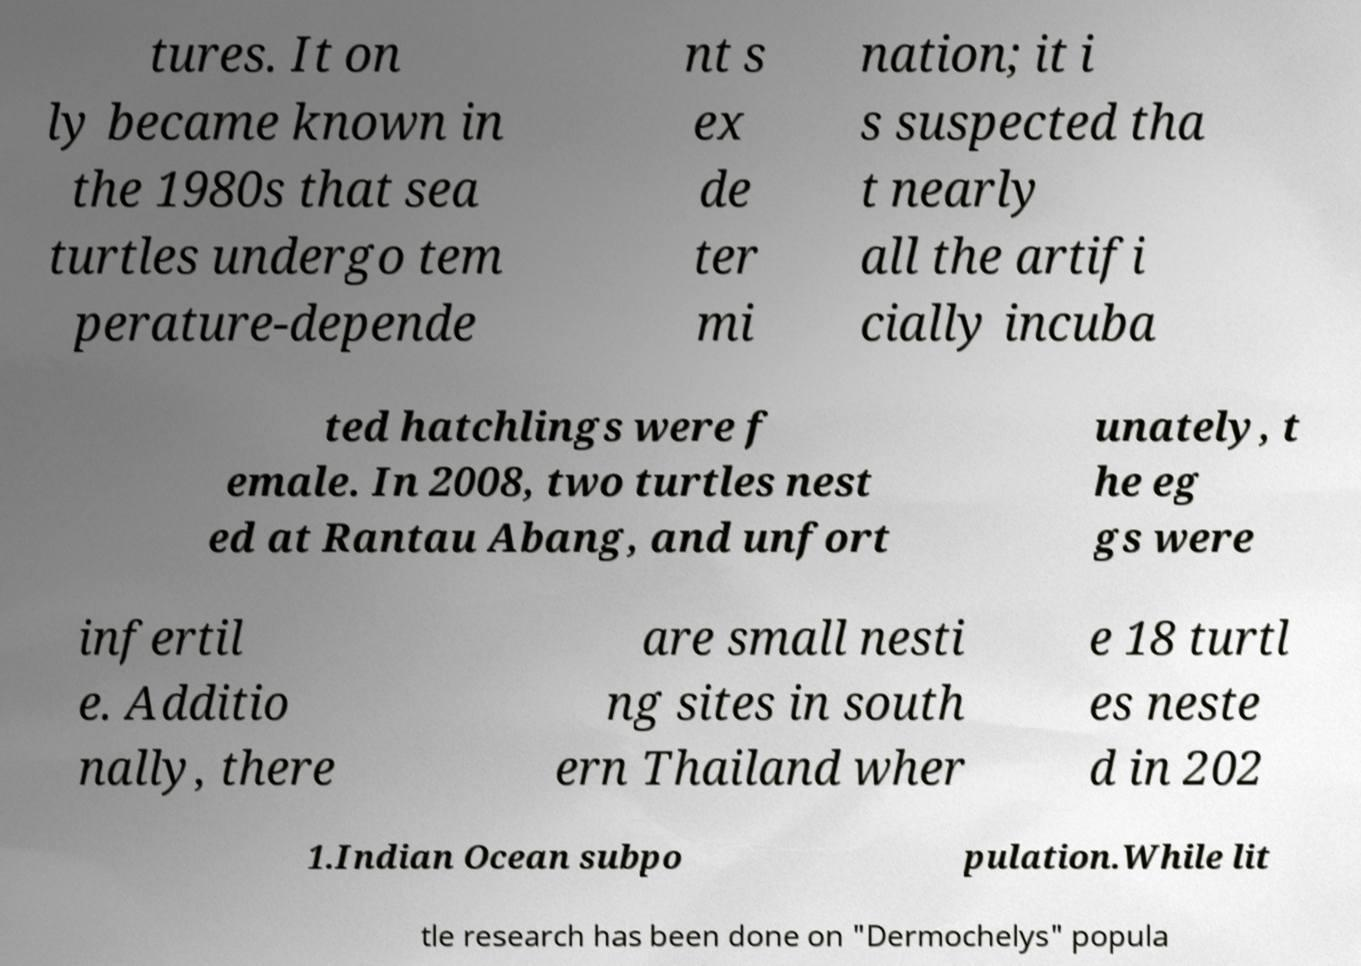Can you read and provide the text displayed in the image?This photo seems to have some interesting text. Can you extract and type it out for me? tures. It on ly became known in the 1980s that sea turtles undergo tem perature-depende nt s ex de ter mi nation; it i s suspected tha t nearly all the artifi cially incuba ted hatchlings were f emale. In 2008, two turtles nest ed at Rantau Abang, and unfort unately, t he eg gs were infertil e. Additio nally, there are small nesti ng sites in south ern Thailand wher e 18 turtl es neste d in 202 1.Indian Ocean subpo pulation.While lit tle research has been done on "Dermochelys" popula 